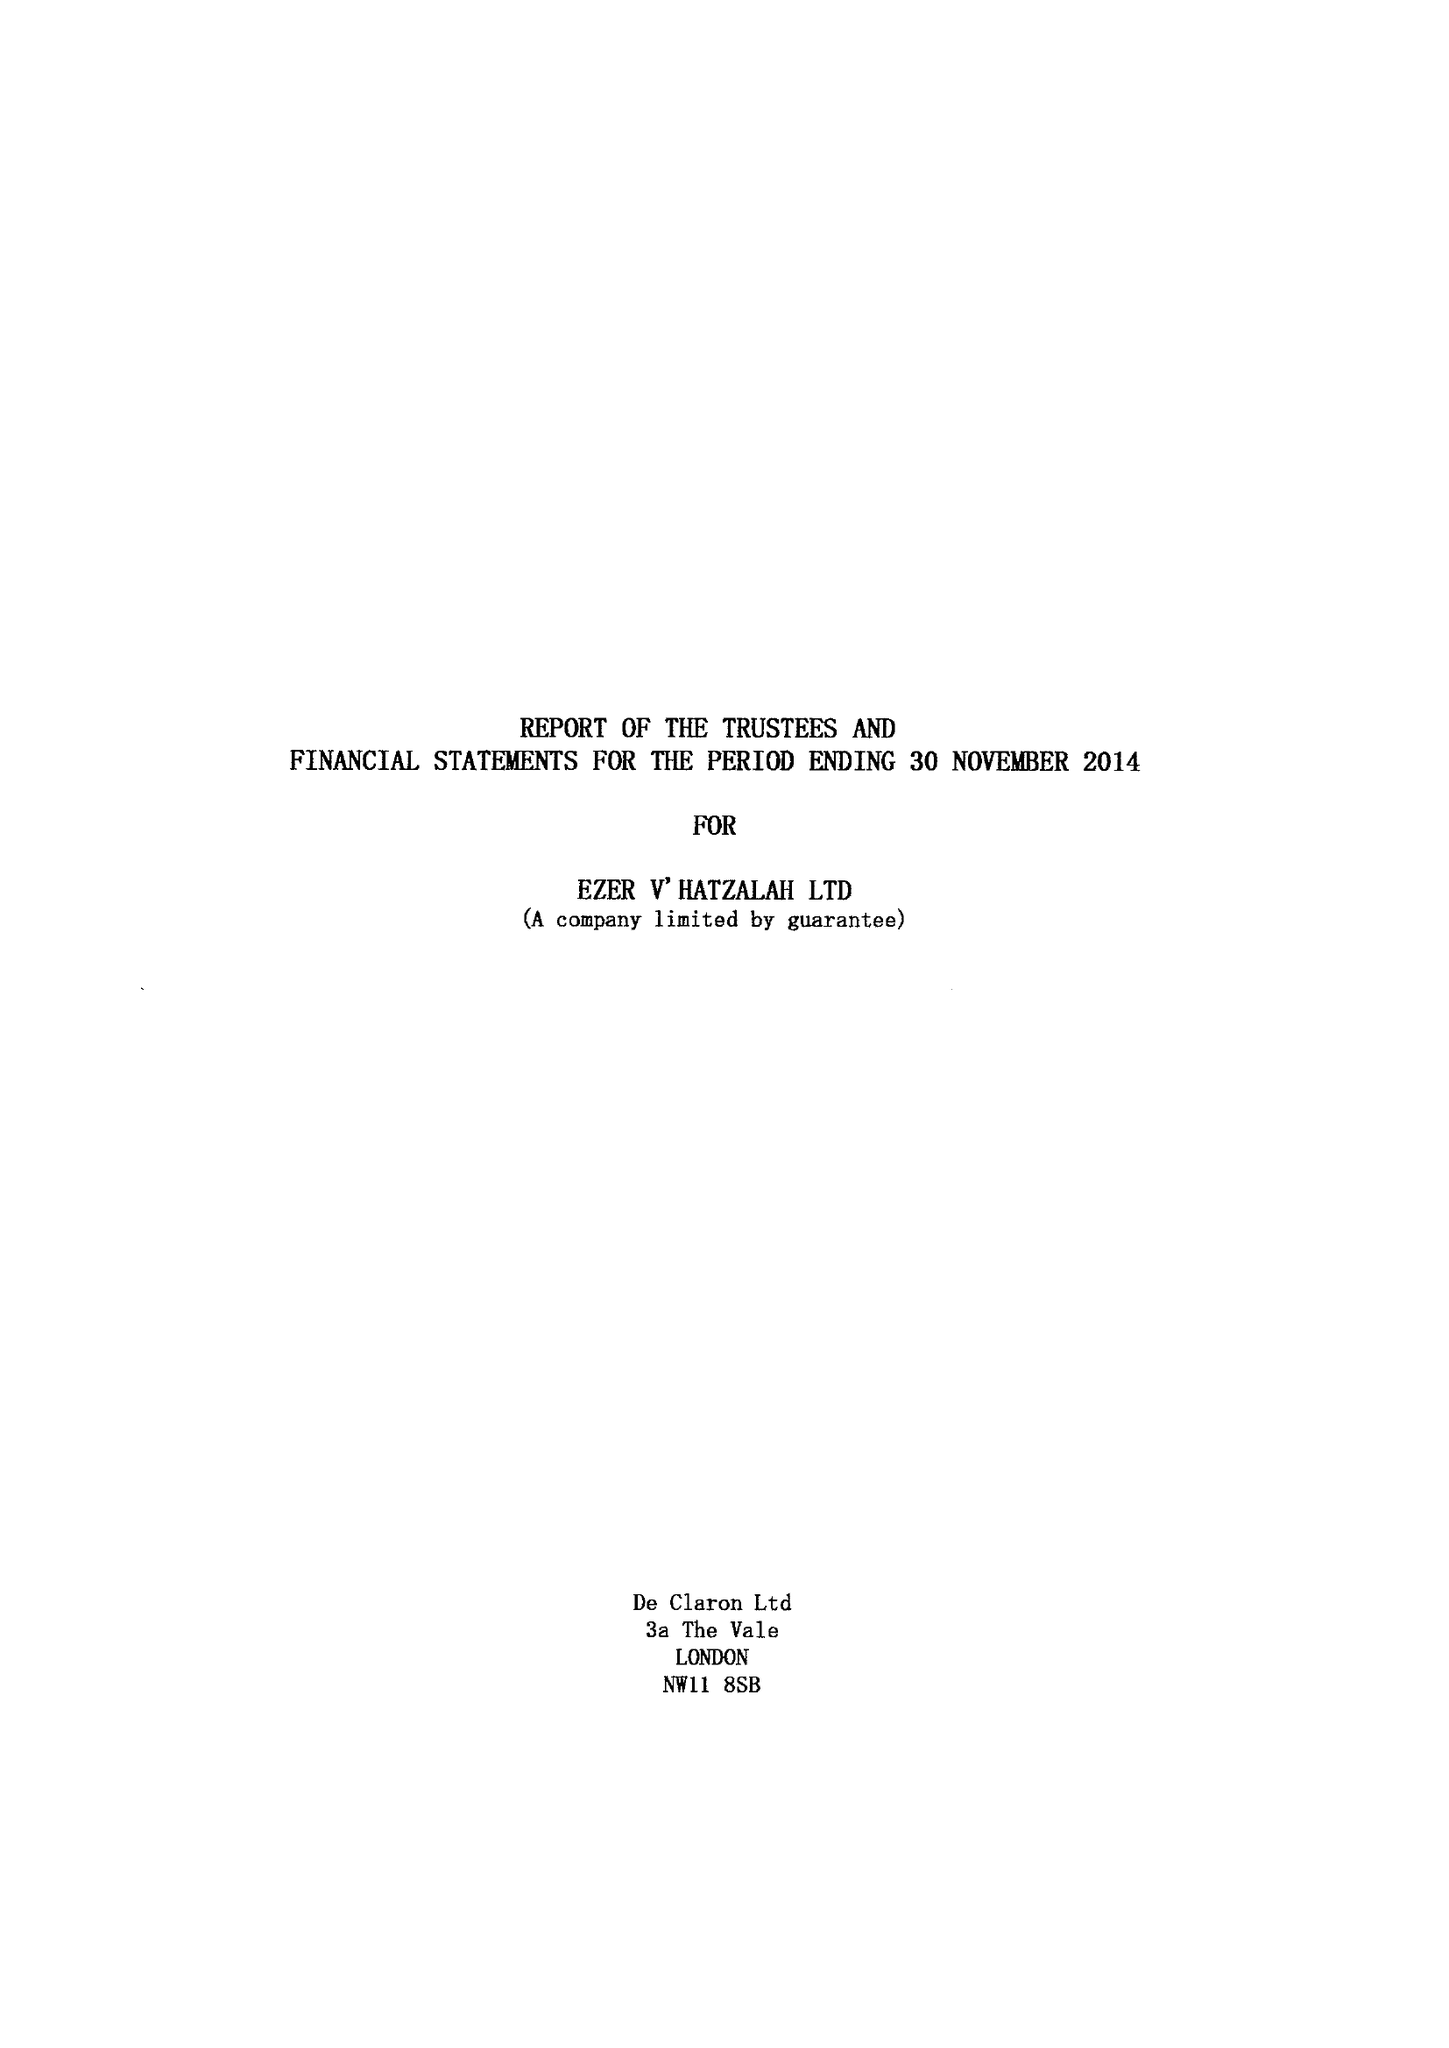What is the value for the charity_number?
Answer the question using a single word or phrase. 1117140 